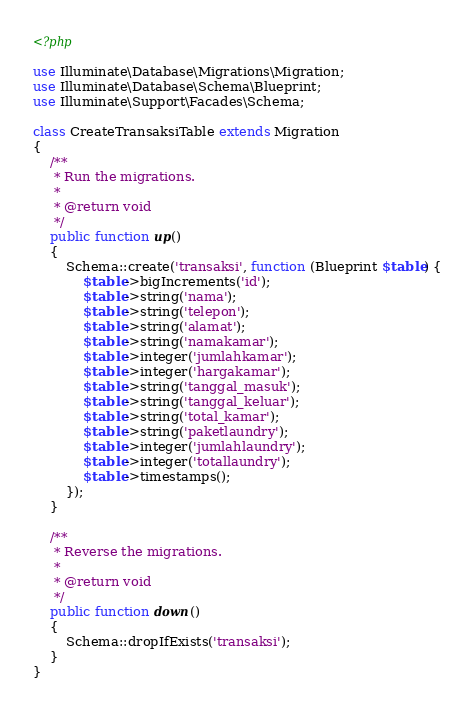Convert code to text. <code><loc_0><loc_0><loc_500><loc_500><_PHP_><?php

use Illuminate\Database\Migrations\Migration;
use Illuminate\Database\Schema\Blueprint;
use Illuminate\Support\Facades\Schema;

class CreateTransaksiTable extends Migration
{
    /**
     * Run the migrations.
     *
     * @return void
     */
    public function up()
    {
        Schema::create('transaksi', function (Blueprint $table) {
            $table->bigIncrements('id');
            $table->string('nama');
            $table->string('telepon');
            $table->string('alamat');
            $table->string('namakamar');
            $table->integer('jumlahkamar');
            $table->integer('hargakamar');
            $table->string('tanggal_masuk');
            $table->string('tanggal_keluar');
            $table->string('total_kamar');
            $table->string('paketlaundry');
            $table->integer('jumlahlaundry');
            $table->integer('totallaundry');
            $table->timestamps();
        });
    }

    /**
     * Reverse the migrations.
     *
     * @return void
     */
    public function down()
    {
        Schema::dropIfExists('transaksi');
    }
}
</code> 